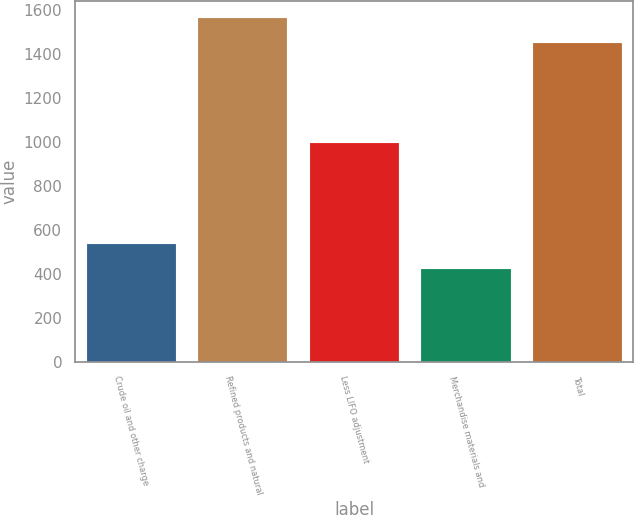<chart> <loc_0><loc_0><loc_500><loc_500><bar_chart><fcel>Crude oil and other charge<fcel>Refined products and natural<fcel>Less LIFO adjustment<fcel>Merchandise materials and<fcel>Total<nl><fcel>533.5<fcel>1562.5<fcel>995<fcel>423<fcel>1452<nl></chart> 